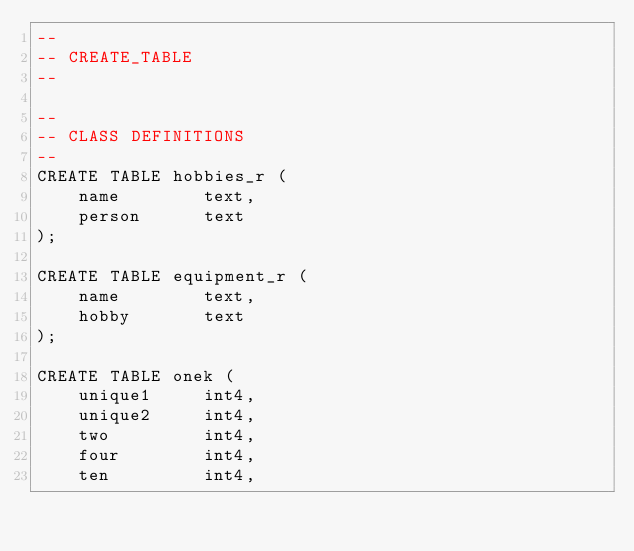Convert code to text. <code><loc_0><loc_0><loc_500><loc_500><_SQL_>--
-- CREATE_TABLE
--

--
-- CLASS DEFINITIONS
--
CREATE TABLE hobbies_r (
	name		text,
	person 		text
);

CREATE TABLE equipment_r (
	name 		text,
	hobby		text
);

CREATE TABLE onek (
	unique1		int4,
	unique2		int4,
	two			int4,
	four		int4,
	ten			int4,</code> 